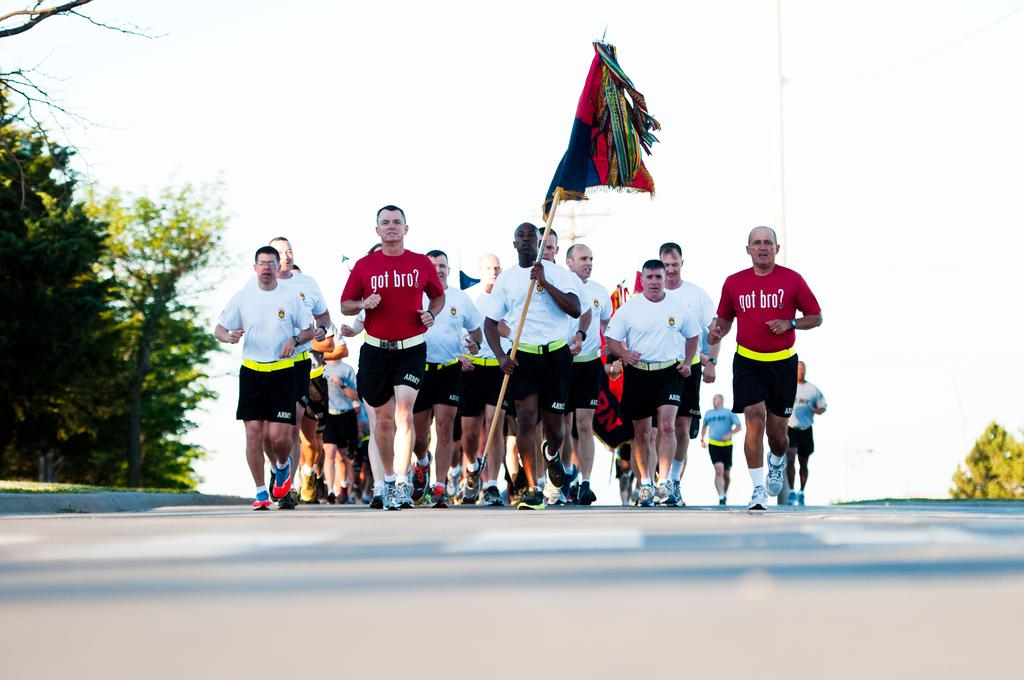What are the people in the image doing? The people in the image are running. Can you describe any specific details about one of the people? One of the people is holding a flag. What can be seen in the background of the image? There are trees in the background of the image. What is visible at the bottom of the image? There is a road at the bottom of the image. What is visible at the top of the image? The sky is visible at the top of the image. What type of cast can be seen on the stage in the image? There is no cast or stage present in the image; it features people running with a flag, trees in the background, a road at the bottom, and sky at the top. 